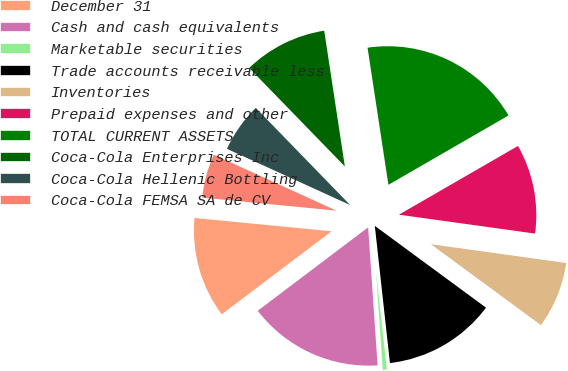<chart> <loc_0><loc_0><loc_500><loc_500><pie_chart><fcel>December 31<fcel>Cash and cash equivalents<fcel>Marketable securities<fcel>Trade accounts receivable less<fcel>Inventories<fcel>Prepaid expenses and other<fcel>TOTAL CURRENT ASSETS<fcel>Coca-Cola Enterprises Inc<fcel>Coca-Cola Hellenic Bottling<fcel>Coca-Cola FEMSA SA de CV<nl><fcel>11.84%<fcel>15.79%<fcel>0.66%<fcel>13.16%<fcel>7.9%<fcel>10.53%<fcel>19.07%<fcel>9.87%<fcel>5.92%<fcel>5.27%<nl></chart> 